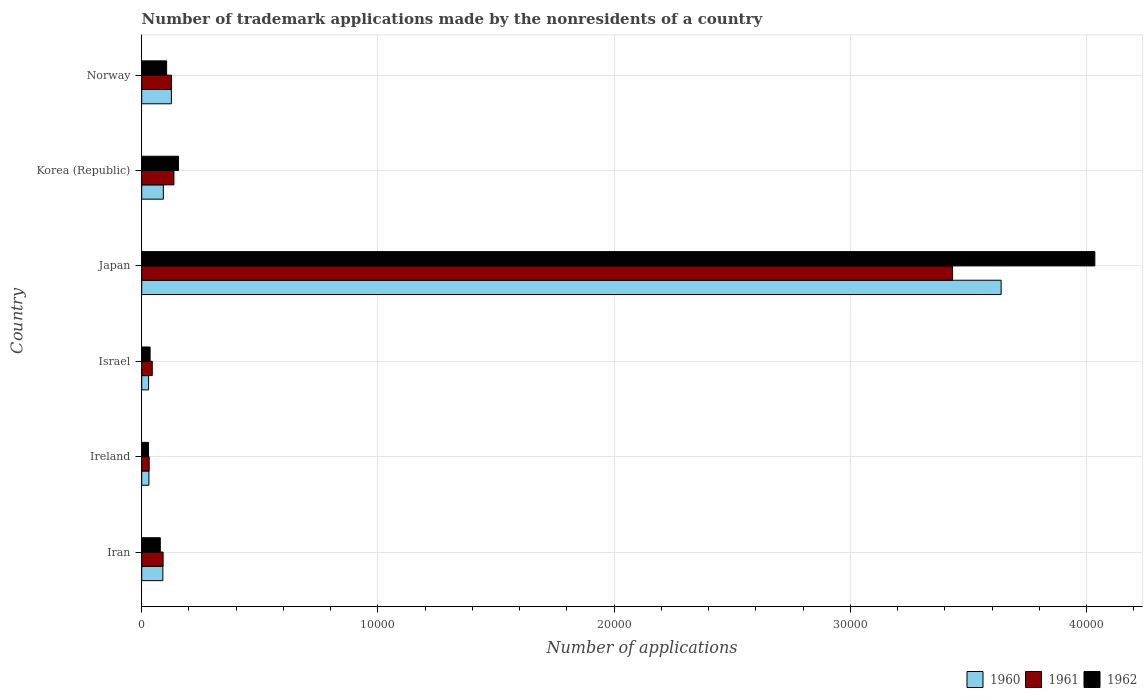How many groups of bars are there?
Offer a very short reply. 6. How many bars are there on the 2nd tick from the top?
Your answer should be compact. 3. What is the number of trademark applications made by the nonresidents in 1960 in Iran?
Offer a very short reply. 895. Across all countries, what is the maximum number of trademark applications made by the nonresidents in 1960?
Your response must be concise. 3.64e+04. Across all countries, what is the minimum number of trademark applications made by the nonresidents in 1961?
Offer a terse response. 316. In which country was the number of trademark applications made by the nonresidents in 1961 maximum?
Give a very brief answer. Japan. In which country was the number of trademark applications made by the nonresidents in 1962 minimum?
Ensure brevity in your answer.  Ireland. What is the total number of trademark applications made by the nonresidents in 1962 in the graph?
Your answer should be compact. 4.44e+04. What is the difference between the number of trademark applications made by the nonresidents in 1960 in Japan and that in Norway?
Ensure brevity in your answer.  3.51e+04. What is the difference between the number of trademark applications made by the nonresidents in 1960 in Israel and the number of trademark applications made by the nonresidents in 1962 in Korea (Republic)?
Your answer should be compact. -1264. What is the average number of trademark applications made by the nonresidents in 1961 per country?
Ensure brevity in your answer.  6434.67. What is the difference between the number of trademark applications made by the nonresidents in 1962 and number of trademark applications made by the nonresidents in 1961 in Israel?
Your answer should be very brief. -91. What is the ratio of the number of trademark applications made by the nonresidents in 1960 in Japan to that in Norway?
Offer a terse response. 28.99. What is the difference between the highest and the second highest number of trademark applications made by the nonresidents in 1961?
Provide a short and direct response. 3.30e+04. What is the difference between the highest and the lowest number of trademark applications made by the nonresidents in 1961?
Offer a terse response. 3.40e+04. In how many countries, is the number of trademark applications made by the nonresidents in 1962 greater than the average number of trademark applications made by the nonresidents in 1962 taken over all countries?
Keep it short and to the point. 1. What does the 2nd bar from the bottom in Ireland represents?
Your answer should be very brief. 1961. What is the difference between two consecutive major ticks on the X-axis?
Offer a terse response. 10000. Are the values on the major ticks of X-axis written in scientific E-notation?
Offer a terse response. No. Where does the legend appear in the graph?
Offer a very short reply. Bottom right. How many legend labels are there?
Your response must be concise. 3. What is the title of the graph?
Keep it short and to the point. Number of trademark applications made by the nonresidents of a country. Does "1979" appear as one of the legend labels in the graph?
Offer a very short reply. No. What is the label or title of the X-axis?
Your answer should be compact. Number of applications. What is the label or title of the Y-axis?
Ensure brevity in your answer.  Country. What is the Number of applications in 1960 in Iran?
Give a very brief answer. 895. What is the Number of applications of 1961 in Iran?
Keep it short and to the point. 905. What is the Number of applications of 1962 in Iran?
Ensure brevity in your answer.  786. What is the Number of applications of 1960 in Ireland?
Ensure brevity in your answer.  305. What is the Number of applications of 1961 in Ireland?
Ensure brevity in your answer.  316. What is the Number of applications of 1962 in Ireland?
Your answer should be very brief. 288. What is the Number of applications in 1960 in Israel?
Your answer should be compact. 290. What is the Number of applications of 1961 in Israel?
Ensure brevity in your answer.  446. What is the Number of applications of 1962 in Israel?
Ensure brevity in your answer.  355. What is the Number of applications of 1960 in Japan?
Offer a very short reply. 3.64e+04. What is the Number of applications of 1961 in Japan?
Provide a succinct answer. 3.43e+04. What is the Number of applications of 1962 in Japan?
Keep it short and to the point. 4.03e+04. What is the Number of applications of 1960 in Korea (Republic)?
Your answer should be compact. 916. What is the Number of applications in 1961 in Korea (Republic)?
Your answer should be compact. 1363. What is the Number of applications in 1962 in Korea (Republic)?
Your answer should be compact. 1554. What is the Number of applications of 1960 in Norway?
Give a very brief answer. 1255. What is the Number of applications in 1961 in Norway?
Your response must be concise. 1258. What is the Number of applications of 1962 in Norway?
Provide a short and direct response. 1055. Across all countries, what is the maximum Number of applications in 1960?
Offer a very short reply. 3.64e+04. Across all countries, what is the maximum Number of applications of 1961?
Offer a very short reply. 3.43e+04. Across all countries, what is the maximum Number of applications of 1962?
Offer a very short reply. 4.03e+04. Across all countries, what is the minimum Number of applications in 1960?
Offer a terse response. 290. Across all countries, what is the minimum Number of applications of 1961?
Your answer should be very brief. 316. Across all countries, what is the minimum Number of applications in 1962?
Make the answer very short. 288. What is the total Number of applications of 1960 in the graph?
Give a very brief answer. 4.00e+04. What is the total Number of applications of 1961 in the graph?
Your answer should be compact. 3.86e+04. What is the total Number of applications in 1962 in the graph?
Your answer should be very brief. 4.44e+04. What is the difference between the Number of applications in 1960 in Iran and that in Ireland?
Provide a short and direct response. 590. What is the difference between the Number of applications of 1961 in Iran and that in Ireland?
Provide a short and direct response. 589. What is the difference between the Number of applications of 1962 in Iran and that in Ireland?
Make the answer very short. 498. What is the difference between the Number of applications of 1960 in Iran and that in Israel?
Keep it short and to the point. 605. What is the difference between the Number of applications of 1961 in Iran and that in Israel?
Your response must be concise. 459. What is the difference between the Number of applications in 1962 in Iran and that in Israel?
Offer a terse response. 431. What is the difference between the Number of applications in 1960 in Iran and that in Japan?
Give a very brief answer. -3.55e+04. What is the difference between the Number of applications in 1961 in Iran and that in Japan?
Provide a short and direct response. -3.34e+04. What is the difference between the Number of applications in 1962 in Iran and that in Japan?
Provide a short and direct response. -3.96e+04. What is the difference between the Number of applications of 1960 in Iran and that in Korea (Republic)?
Your answer should be very brief. -21. What is the difference between the Number of applications of 1961 in Iran and that in Korea (Republic)?
Your answer should be compact. -458. What is the difference between the Number of applications of 1962 in Iran and that in Korea (Republic)?
Make the answer very short. -768. What is the difference between the Number of applications of 1960 in Iran and that in Norway?
Ensure brevity in your answer.  -360. What is the difference between the Number of applications in 1961 in Iran and that in Norway?
Your answer should be very brief. -353. What is the difference between the Number of applications in 1962 in Iran and that in Norway?
Offer a very short reply. -269. What is the difference between the Number of applications in 1960 in Ireland and that in Israel?
Ensure brevity in your answer.  15. What is the difference between the Number of applications of 1961 in Ireland and that in Israel?
Provide a succinct answer. -130. What is the difference between the Number of applications of 1962 in Ireland and that in Israel?
Keep it short and to the point. -67. What is the difference between the Number of applications of 1960 in Ireland and that in Japan?
Offer a very short reply. -3.61e+04. What is the difference between the Number of applications in 1961 in Ireland and that in Japan?
Your answer should be very brief. -3.40e+04. What is the difference between the Number of applications in 1962 in Ireland and that in Japan?
Provide a short and direct response. -4.01e+04. What is the difference between the Number of applications of 1960 in Ireland and that in Korea (Republic)?
Offer a terse response. -611. What is the difference between the Number of applications of 1961 in Ireland and that in Korea (Republic)?
Your answer should be compact. -1047. What is the difference between the Number of applications of 1962 in Ireland and that in Korea (Republic)?
Give a very brief answer. -1266. What is the difference between the Number of applications in 1960 in Ireland and that in Norway?
Your answer should be very brief. -950. What is the difference between the Number of applications of 1961 in Ireland and that in Norway?
Your answer should be compact. -942. What is the difference between the Number of applications in 1962 in Ireland and that in Norway?
Provide a succinct answer. -767. What is the difference between the Number of applications of 1960 in Israel and that in Japan?
Your response must be concise. -3.61e+04. What is the difference between the Number of applications in 1961 in Israel and that in Japan?
Your response must be concise. -3.39e+04. What is the difference between the Number of applications of 1962 in Israel and that in Japan?
Offer a very short reply. -4.00e+04. What is the difference between the Number of applications in 1960 in Israel and that in Korea (Republic)?
Ensure brevity in your answer.  -626. What is the difference between the Number of applications of 1961 in Israel and that in Korea (Republic)?
Make the answer very short. -917. What is the difference between the Number of applications of 1962 in Israel and that in Korea (Republic)?
Ensure brevity in your answer.  -1199. What is the difference between the Number of applications in 1960 in Israel and that in Norway?
Provide a succinct answer. -965. What is the difference between the Number of applications in 1961 in Israel and that in Norway?
Provide a succinct answer. -812. What is the difference between the Number of applications of 1962 in Israel and that in Norway?
Your answer should be very brief. -700. What is the difference between the Number of applications in 1960 in Japan and that in Korea (Republic)?
Provide a succinct answer. 3.55e+04. What is the difference between the Number of applications in 1961 in Japan and that in Korea (Republic)?
Offer a very short reply. 3.30e+04. What is the difference between the Number of applications in 1962 in Japan and that in Korea (Republic)?
Provide a short and direct response. 3.88e+04. What is the difference between the Number of applications of 1960 in Japan and that in Norway?
Provide a succinct answer. 3.51e+04. What is the difference between the Number of applications in 1961 in Japan and that in Norway?
Your answer should be compact. 3.31e+04. What is the difference between the Number of applications of 1962 in Japan and that in Norway?
Provide a succinct answer. 3.93e+04. What is the difference between the Number of applications of 1960 in Korea (Republic) and that in Norway?
Ensure brevity in your answer.  -339. What is the difference between the Number of applications in 1961 in Korea (Republic) and that in Norway?
Offer a very short reply. 105. What is the difference between the Number of applications of 1962 in Korea (Republic) and that in Norway?
Offer a very short reply. 499. What is the difference between the Number of applications of 1960 in Iran and the Number of applications of 1961 in Ireland?
Ensure brevity in your answer.  579. What is the difference between the Number of applications in 1960 in Iran and the Number of applications in 1962 in Ireland?
Ensure brevity in your answer.  607. What is the difference between the Number of applications of 1961 in Iran and the Number of applications of 1962 in Ireland?
Provide a succinct answer. 617. What is the difference between the Number of applications of 1960 in Iran and the Number of applications of 1961 in Israel?
Your response must be concise. 449. What is the difference between the Number of applications of 1960 in Iran and the Number of applications of 1962 in Israel?
Provide a short and direct response. 540. What is the difference between the Number of applications of 1961 in Iran and the Number of applications of 1962 in Israel?
Give a very brief answer. 550. What is the difference between the Number of applications of 1960 in Iran and the Number of applications of 1961 in Japan?
Your response must be concise. -3.34e+04. What is the difference between the Number of applications of 1960 in Iran and the Number of applications of 1962 in Japan?
Offer a very short reply. -3.94e+04. What is the difference between the Number of applications in 1961 in Iran and the Number of applications in 1962 in Japan?
Your answer should be compact. -3.94e+04. What is the difference between the Number of applications in 1960 in Iran and the Number of applications in 1961 in Korea (Republic)?
Ensure brevity in your answer.  -468. What is the difference between the Number of applications of 1960 in Iran and the Number of applications of 1962 in Korea (Republic)?
Your response must be concise. -659. What is the difference between the Number of applications of 1961 in Iran and the Number of applications of 1962 in Korea (Republic)?
Make the answer very short. -649. What is the difference between the Number of applications of 1960 in Iran and the Number of applications of 1961 in Norway?
Your answer should be compact. -363. What is the difference between the Number of applications of 1960 in Iran and the Number of applications of 1962 in Norway?
Offer a very short reply. -160. What is the difference between the Number of applications of 1961 in Iran and the Number of applications of 1962 in Norway?
Your answer should be very brief. -150. What is the difference between the Number of applications of 1960 in Ireland and the Number of applications of 1961 in Israel?
Keep it short and to the point. -141. What is the difference between the Number of applications of 1961 in Ireland and the Number of applications of 1962 in Israel?
Make the answer very short. -39. What is the difference between the Number of applications of 1960 in Ireland and the Number of applications of 1961 in Japan?
Your answer should be compact. -3.40e+04. What is the difference between the Number of applications of 1960 in Ireland and the Number of applications of 1962 in Japan?
Make the answer very short. -4.00e+04. What is the difference between the Number of applications of 1961 in Ireland and the Number of applications of 1962 in Japan?
Your answer should be very brief. -4.00e+04. What is the difference between the Number of applications in 1960 in Ireland and the Number of applications in 1961 in Korea (Republic)?
Ensure brevity in your answer.  -1058. What is the difference between the Number of applications in 1960 in Ireland and the Number of applications in 1962 in Korea (Republic)?
Offer a terse response. -1249. What is the difference between the Number of applications in 1961 in Ireland and the Number of applications in 1962 in Korea (Republic)?
Provide a succinct answer. -1238. What is the difference between the Number of applications of 1960 in Ireland and the Number of applications of 1961 in Norway?
Your answer should be compact. -953. What is the difference between the Number of applications of 1960 in Ireland and the Number of applications of 1962 in Norway?
Your answer should be very brief. -750. What is the difference between the Number of applications of 1961 in Ireland and the Number of applications of 1962 in Norway?
Offer a terse response. -739. What is the difference between the Number of applications of 1960 in Israel and the Number of applications of 1961 in Japan?
Provide a short and direct response. -3.40e+04. What is the difference between the Number of applications in 1960 in Israel and the Number of applications in 1962 in Japan?
Your response must be concise. -4.01e+04. What is the difference between the Number of applications in 1961 in Israel and the Number of applications in 1962 in Japan?
Provide a short and direct response. -3.99e+04. What is the difference between the Number of applications in 1960 in Israel and the Number of applications in 1961 in Korea (Republic)?
Provide a short and direct response. -1073. What is the difference between the Number of applications in 1960 in Israel and the Number of applications in 1962 in Korea (Republic)?
Your response must be concise. -1264. What is the difference between the Number of applications in 1961 in Israel and the Number of applications in 1962 in Korea (Republic)?
Provide a succinct answer. -1108. What is the difference between the Number of applications in 1960 in Israel and the Number of applications in 1961 in Norway?
Provide a succinct answer. -968. What is the difference between the Number of applications in 1960 in Israel and the Number of applications in 1962 in Norway?
Your answer should be compact. -765. What is the difference between the Number of applications of 1961 in Israel and the Number of applications of 1962 in Norway?
Ensure brevity in your answer.  -609. What is the difference between the Number of applications of 1960 in Japan and the Number of applications of 1961 in Korea (Republic)?
Offer a terse response. 3.50e+04. What is the difference between the Number of applications of 1960 in Japan and the Number of applications of 1962 in Korea (Republic)?
Keep it short and to the point. 3.48e+04. What is the difference between the Number of applications of 1961 in Japan and the Number of applications of 1962 in Korea (Republic)?
Offer a very short reply. 3.28e+04. What is the difference between the Number of applications of 1960 in Japan and the Number of applications of 1961 in Norway?
Your answer should be very brief. 3.51e+04. What is the difference between the Number of applications of 1960 in Japan and the Number of applications of 1962 in Norway?
Offer a very short reply. 3.53e+04. What is the difference between the Number of applications in 1961 in Japan and the Number of applications in 1962 in Norway?
Offer a very short reply. 3.33e+04. What is the difference between the Number of applications in 1960 in Korea (Republic) and the Number of applications in 1961 in Norway?
Give a very brief answer. -342. What is the difference between the Number of applications in 1960 in Korea (Republic) and the Number of applications in 1962 in Norway?
Offer a very short reply. -139. What is the difference between the Number of applications in 1961 in Korea (Republic) and the Number of applications in 1962 in Norway?
Offer a terse response. 308. What is the average Number of applications of 1960 per country?
Make the answer very short. 6673. What is the average Number of applications of 1961 per country?
Your answer should be compact. 6434.67. What is the average Number of applications of 1962 per country?
Provide a short and direct response. 7396.83. What is the difference between the Number of applications in 1960 and Number of applications in 1961 in Iran?
Your answer should be very brief. -10. What is the difference between the Number of applications of 1960 and Number of applications of 1962 in Iran?
Your response must be concise. 109. What is the difference between the Number of applications in 1961 and Number of applications in 1962 in Iran?
Your answer should be very brief. 119. What is the difference between the Number of applications in 1960 and Number of applications in 1961 in Israel?
Keep it short and to the point. -156. What is the difference between the Number of applications of 1960 and Number of applications of 1962 in Israel?
Your answer should be very brief. -65. What is the difference between the Number of applications in 1961 and Number of applications in 1962 in Israel?
Your answer should be very brief. 91. What is the difference between the Number of applications in 1960 and Number of applications in 1961 in Japan?
Provide a short and direct response. 2057. What is the difference between the Number of applications in 1960 and Number of applications in 1962 in Japan?
Offer a very short reply. -3966. What is the difference between the Number of applications in 1961 and Number of applications in 1962 in Japan?
Your answer should be very brief. -6023. What is the difference between the Number of applications in 1960 and Number of applications in 1961 in Korea (Republic)?
Your answer should be very brief. -447. What is the difference between the Number of applications of 1960 and Number of applications of 1962 in Korea (Republic)?
Offer a very short reply. -638. What is the difference between the Number of applications in 1961 and Number of applications in 1962 in Korea (Republic)?
Offer a very short reply. -191. What is the difference between the Number of applications of 1961 and Number of applications of 1962 in Norway?
Offer a very short reply. 203. What is the ratio of the Number of applications in 1960 in Iran to that in Ireland?
Offer a terse response. 2.93. What is the ratio of the Number of applications of 1961 in Iran to that in Ireland?
Offer a very short reply. 2.86. What is the ratio of the Number of applications in 1962 in Iran to that in Ireland?
Your answer should be compact. 2.73. What is the ratio of the Number of applications in 1960 in Iran to that in Israel?
Keep it short and to the point. 3.09. What is the ratio of the Number of applications in 1961 in Iran to that in Israel?
Your response must be concise. 2.03. What is the ratio of the Number of applications of 1962 in Iran to that in Israel?
Give a very brief answer. 2.21. What is the ratio of the Number of applications of 1960 in Iran to that in Japan?
Make the answer very short. 0.02. What is the ratio of the Number of applications of 1961 in Iran to that in Japan?
Your response must be concise. 0.03. What is the ratio of the Number of applications of 1962 in Iran to that in Japan?
Your answer should be very brief. 0.02. What is the ratio of the Number of applications in 1960 in Iran to that in Korea (Republic)?
Provide a succinct answer. 0.98. What is the ratio of the Number of applications in 1961 in Iran to that in Korea (Republic)?
Your answer should be compact. 0.66. What is the ratio of the Number of applications in 1962 in Iran to that in Korea (Republic)?
Your answer should be compact. 0.51. What is the ratio of the Number of applications of 1960 in Iran to that in Norway?
Provide a succinct answer. 0.71. What is the ratio of the Number of applications of 1961 in Iran to that in Norway?
Your response must be concise. 0.72. What is the ratio of the Number of applications of 1962 in Iran to that in Norway?
Ensure brevity in your answer.  0.74. What is the ratio of the Number of applications of 1960 in Ireland to that in Israel?
Provide a succinct answer. 1.05. What is the ratio of the Number of applications in 1961 in Ireland to that in Israel?
Offer a terse response. 0.71. What is the ratio of the Number of applications in 1962 in Ireland to that in Israel?
Make the answer very short. 0.81. What is the ratio of the Number of applications in 1960 in Ireland to that in Japan?
Give a very brief answer. 0.01. What is the ratio of the Number of applications in 1961 in Ireland to that in Japan?
Offer a terse response. 0.01. What is the ratio of the Number of applications of 1962 in Ireland to that in Japan?
Make the answer very short. 0.01. What is the ratio of the Number of applications of 1960 in Ireland to that in Korea (Republic)?
Give a very brief answer. 0.33. What is the ratio of the Number of applications of 1961 in Ireland to that in Korea (Republic)?
Give a very brief answer. 0.23. What is the ratio of the Number of applications of 1962 in Ireland to that in Korea (Republic)?
Give a very brief answer. 0.19. What is the ratio of the Number of applications of 1960 in Ireland to that in Norway?
Provide a succinct answer. 0.24. What is the ratio of the Number of applications in 1961 in Ireland to that in Norway?
Provide a succinct answer. 0.25. What is the ratio of the Number of applications of 1962 in Ireland to that in Norway?
Offer a terse response. 0.27. What is the ratio of the Number of applications in 1960 in Israel to that in Japan?
Provide a succinct answer. 0.01. What is the ratio of the Number of applications of 1961 in Israel to that in Japan?
Your answer should be very brief. 0.01. What is the ratio of the Number of applications of 1962 in Israel to that in Japan?
Provide a succinct answer. 0.01. What is the ratio of the Number of applications in 1960 in Israel to that in Korea (Republic)?
Ensure brevity in your answer.  0.32. What is the ratio of the Number of applications of 1961 in Israel to that in Korea (Republic)?
Your answer should be compact. 0.33. What is the ratio of the Number of applications in 1962 in Israel to that in Korea (Republic)?
Keep it short and to the point. 0.23. What is the ratio of the Number of applications of 1960 in Israel to that in Norway?
Your response must be concise. 0.23. What is the ratio of the Number of applications of 1961 in Israel to that in Norway?
Your answer should be compact. 0.35. What is the ratio of the Number of applications in 1962 in Israel to that in Norway?
Give a very brief answer. 0.34. What is the ratio of the Number of applications of 1960 in Japan to that in Korea (Republic)?
Offer a terse response. 39.71. What is the ratio of the Number of applications in 1961 in Japan to that in Korea (Republic)?
Make the answer very short. 25.18. What is the ratio of the Number of applications in 1962 in Japan to that in Korea (Republic)?
Keep it short and to the point. 25.96. What is the ratio of the Number of applications in 1960 in Japan to that in Norway?
Your response must be concise. 28.99. What is the ratio of the Number of applications in 1961 in Japan to that in Norway?
Keep it short and to the point. 27.28. What is the ratio of the Number of applications of 1962 in Japan to that in Norway?
Your response must be concise. 38.24. What is the ratio of the Number of applications in 1960 in Korea (Republic) to that in Norway?
Offer a very short reply. 0.73. What is the ratio of the Number of applications of 1961 in Korea (Republic) to that in Norway?
Keep it short and to the point. 1.08. What is the ratio of the Number of applications of 1962 in Korea (Republic) to that in Norway?
Your answer should be very brief. 1.47. What is the difference between the highest and the second highest Number of applications in 1960?
Make the answer very short. 3.51e+04. What is the difference between the highest and the second highest Number of applications of 1961?
Your answer should be very brief. 3.30e+04. What is the difference between the highest and the second highest Number of applications in 1962?
Make the answer very short. 3.88e+04. What is the difference between the highest and the lowest Number of applications of 1960?
Your answer should be compact. 3.61e+04. What is the difference between the highest and the lowest Number of applications in 1961?
Provide a short and direct response. 3.40e+04. What is the difference between the highest and the lowest Number of applications in 1962?
Your answer should be compact. 4.01e+04. 